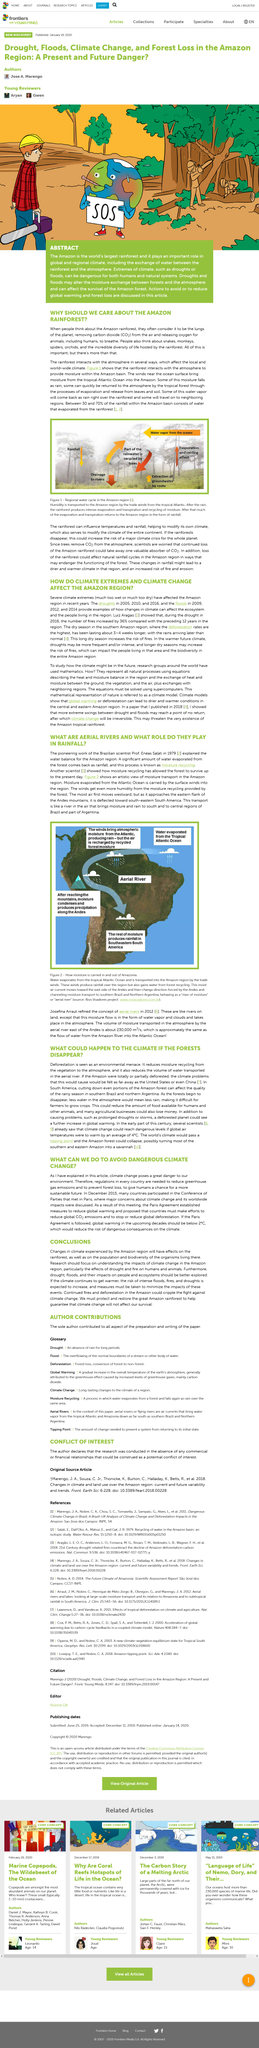Give some essential details in this illustration. The Amazon rainforest interacts with the atmosphere to provide moisture within the Amazon basin. In this article, the types of extreme climates mentioned are droughts and floods. The river of moisture crosses two countries, Brazil and Argentina. The water in the Atlantic Ocean is transported to the Amazon region by the trade winds. Approximately 30% to 70% of the rainfall within the Amazon basin is composed of water that has evaporated from the rainforest. 